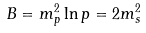Convert formula to latex. <formula><loc_0><loc_0><loc_500><loc_500>B = m _ { p } ^ { 2 } \ln p = 2 m _ { s } ^ { 2 }</formula> 